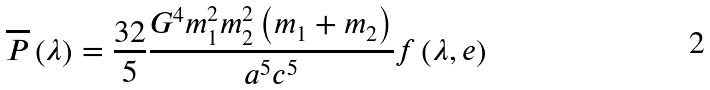Convert formula to latex. <formula><loc_0><loc_0><loc_500><loc_500>\overline { P } \left ( \lambda \right ) = \frac { 3 2 } { 5 } \frac { { G ^ { 4 } m _ { 1 } ^ { 2 } m _ { 2 } ^ { 2 } \left ( { m _ { 1 } + m _ { 2 } } \right ) } } { a ^ { 5 } c ^ { 5 } } f \left ( { \lambda , e } \right )</formula> 